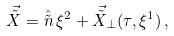<formula> <loc_0><loc_0><loc_500><loc_500>\vec { \tilde { X } } = \hat { \tilde { n } } \, \xi ^ { 2 } + \vec { \tilde { X } } _ { \perp } ( \tau , \xi ^ { 1 } ) \, ,</formula> 